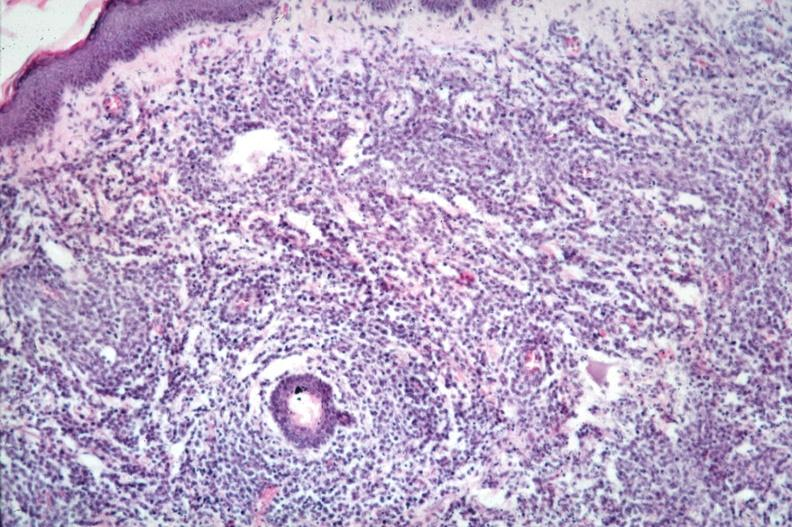s gross present?
Answer the question using a single word or phrase. No 